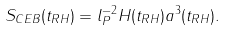Convert formula to latex. <formula><loc_0><loc_0><loc_500><loc_500>S _ { C E B } ( t _ { R H } ) = l _ { P } ^ { - 2 } H ( t _ { R H } ) a ^ { 3 } ( t _ { R H } ) .</formula> 